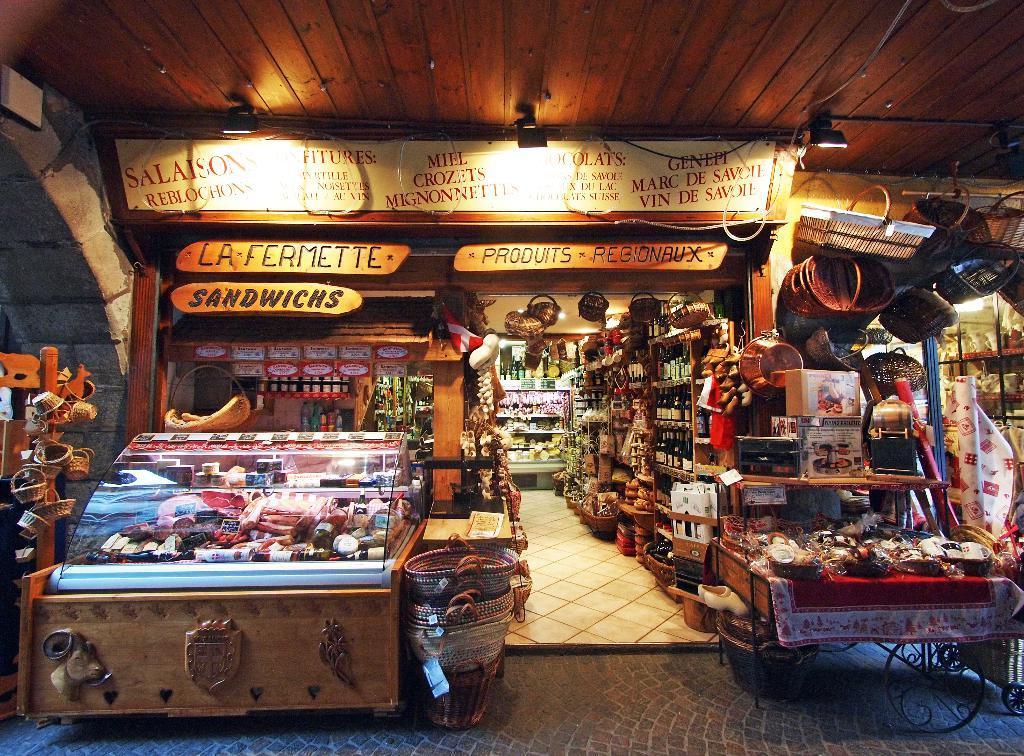<image>
Summarize the visual content of the image. a sandwich sign is in the store above everything 